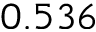Convert formula to latex. <formula><loc_0><loc_0><loc_500><loc_500>0 . 5 3 6</formula> 